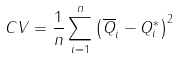Convert formula to latex. <formula><loc_0><loc_0><loc_500><loc_500>C V = \frac { 1 } { n } \sum _ { i = 1 } ^ { n } \left ( \overline { Q } _ { i } - Q _ { i } ^ { \ast } \right ) ^ { 2 }</formula> 